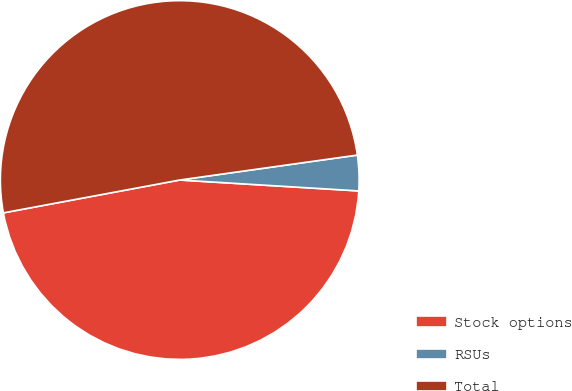<chart> <loc_0><loc_0><loc_500><loc_500><pie_chart><fcel>Stock options<fcel>RSUs<fcel>Total<nl><fcel>46.1%<fcel>3.19%<fcel>50.71%<nl></chart> 